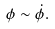Convert formula to latex. <formula><loc_0><loc_0><loc_500><loc_500>\phi \sim \dot { \phi } .</formula> 